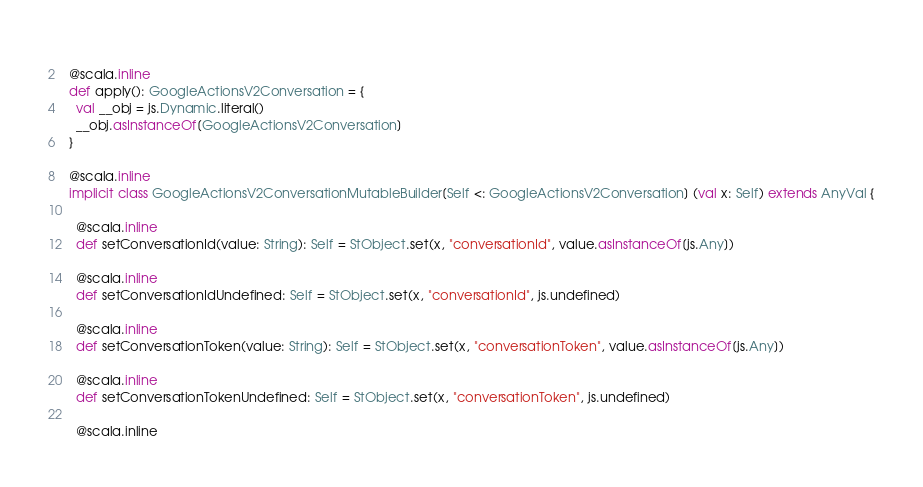Convert code to text. <code><loc_0><loc_0><loc_500><loc_500><_Scala_>  
  @scala.inline
  def apply(): GoogleActionsV2Conversation = {
    val __obj = js.Dynamic.literal()
    __obj.asInstanceOf[GoogleActionsV2Conversation]
  }
  
  @scala.inline
  implicit class GoogleActionsV2ConversationMutableBuilder[Self <: GoogleActionsV2Conversation] (val x: Self) extends AnyVal {
    
    @scala.inline
    def setConversationId(value: String): Self = StObject.set(x, "conversationId", value.asInstanceOf[js.Any])
    
    @scala.inline
    def setConversationIdUndefined: Self = StObject.set(x, "conversationId", js.undefined)
    
    @scala.inline
    def setConversationToken(value: String): Self = StObject.set(x, "conversationToken", value.asInstanceOf[js.Any])
    
    @scala.inline
    def setConversationTokenUndefined: Self = StObject.set(x, "conversationToken", js.undefined)
    
    @scala.inline</code> 